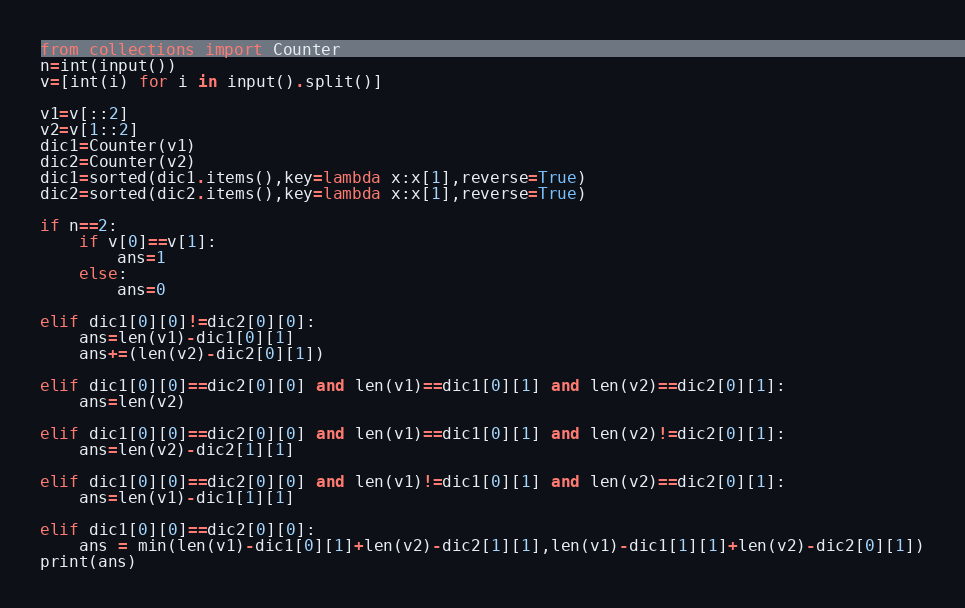Convert code to text. <code><loc_0><loc_0><loc_500><loc_500><_Python_>from collections import Counter
n=int(input())
v=[int(i) for i in input().split()]

v1=v[::2]
v2=v[1::2]
dic1=Counter(v1)
dic2=Counter(v2)
dic1=sorted(dic1.items(),key=lambda x:x[1],reverse=True)
dic2=sorted(dic2.items(),key=lambda x:x[1],reverse=True)

if n==2:
    if v[0]==v[1]:
        ans=1
    else:
        ans=0

elif dic1[0][0]!=dic2[0][0]:
    ans=len(v1)-dic1[0][1]
    ans+=(len(v2)-dic2[0][1])

elif dic1[0][0]==dic2[0][0] and len(v1)==dic1[0][1] and len(v2)==dic2[0][1]:
    ans=len(v2)

elif dic1[0][0]==dic2[0][0] and len(v1)==dic1[0][1] and len(v2)!=dic2[0][1]:
    ans=len(v2)-dic2[1][1]
    
elif dic1[0][0]==dic2[0][0] and len(v1)!=dic1[0][1] and len(v2)==dic2[0][1]:
    ans=len(v1)-dic1[1][1]
    
elif dic1[0][0]==dic2[0][0]:
    ans = min(len(v1)-dic1[0][1]+len(v2)-dic2[1][1],len(v1)-dic1[1][1]+len(v2)-dic2[0][1])
print(ans)
</code> 